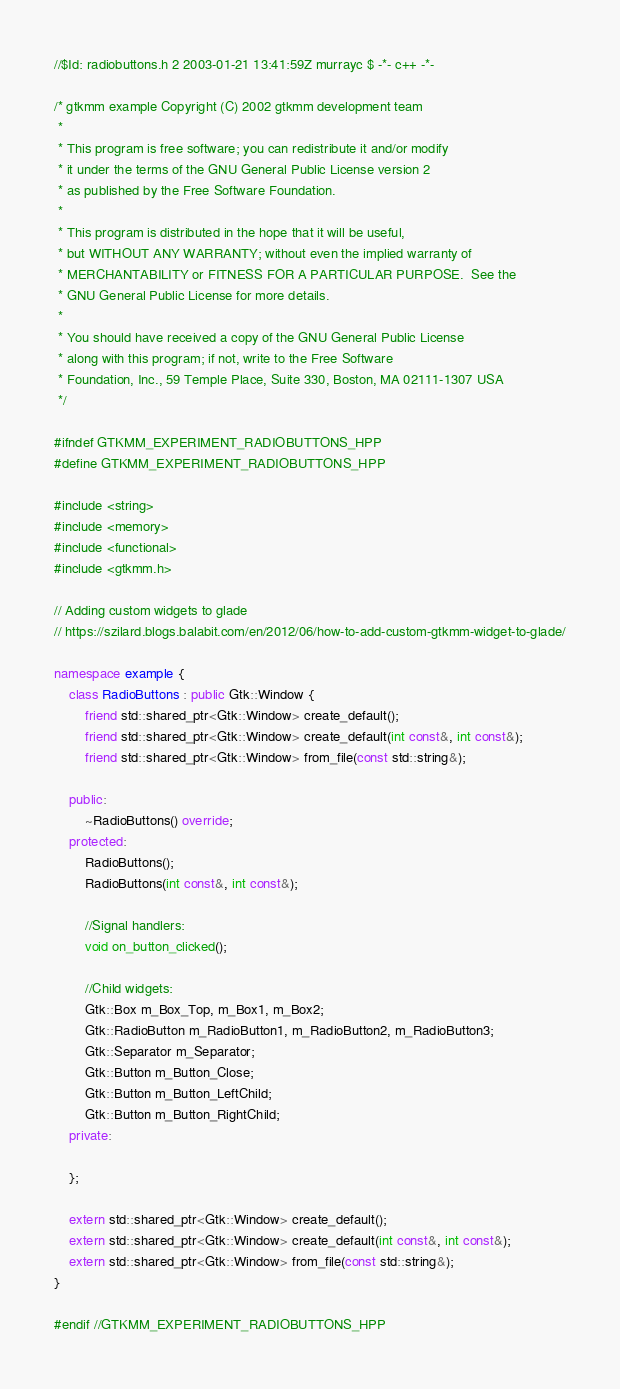Convert code to text. <code><loc_0><loc_0><loc_500><loc_500><_C++_>//$Id: radiobuttons.h 2 2003-01-21 13:41:59Z murrayc $ -*- c++ -*-

/* gtkmm example Copyright (C) 2002 gtkmm development team
 *
 * This program is free software; you can redistribute it and/or modify
 * it under the terms of the GNU General Public License version 2
 * as published by the Free Software Foundation.
 *
 * This program is distributed in the hope that it will be useful,
 * but WITHOUT ANY WARRANTY; without even the implied warranty of
 * MERCHANTABILITY or FITNESS FOR A PARTICULAR PURPOSE.  See the
 * GNU General Public License for more details.
 *
 * You should have received a copy of the GNU General Public License
 * along with this program; if not, write to the Free Software
 * Foundation, Inc., 59 Temple Place, Suite 330, Boston, MA 02111-1307 USA
 */

#ifndef GTKMM_EXPERIMENT_RADIOBUTTONS_HPP
#define GTKMM_EXPERIMENT_RADIOBUTTONS_HPP

#include <string>
#include <memory>
#include <functional>
#include <gtkmm.h>

// Adding custom widgets to glade
// https://szilard.blogs.balabit.com/en/2012/06/how-to-add-custom-gtkmm-widget-to-glade/

namespace example {
    class RadioButtons : public Gtk::Window {
        friend std::shared_ptr<Gtk::Window> create_default();
        friend std::shared_ptr<Gtk::Window> create_default(int const&, int const&);
        friend std::shared_ptr<Gtk::Window> from_file(const std::string&);

    public:
        ~RadioButtons() override;
    protected:
        RadioButtons();
        RadioButtons(int const&, int const&);

        //Signal handlers:
        void on_button_clicked();

        //Child widgets:
        Gtk::Box m_Box_Top, m_Box1, m_Box2;
        Gtk::RadioButton m_RadioButton1, m_RadioButton2, m_RadioButton3;
        Gtk::Separator m_Separator;
        Gtk::Button m_Button_Close;
        Gtk::Button m_Button_LeftChild;
        Gtk::Button m_Button_RightChild;
    private:

    };

    extern std::shared_ptr<Gtk::Window> create_default();
    extern std::shared_ptr<Gtk::Window> create_default(int const&, int const&);
    extern std::shared_ptr<Gtk::Window> from_file(const std::string&);
}

#endif //GTKMM_EXPERIMENT_RADIOBUTTONS_HPP
</code> 